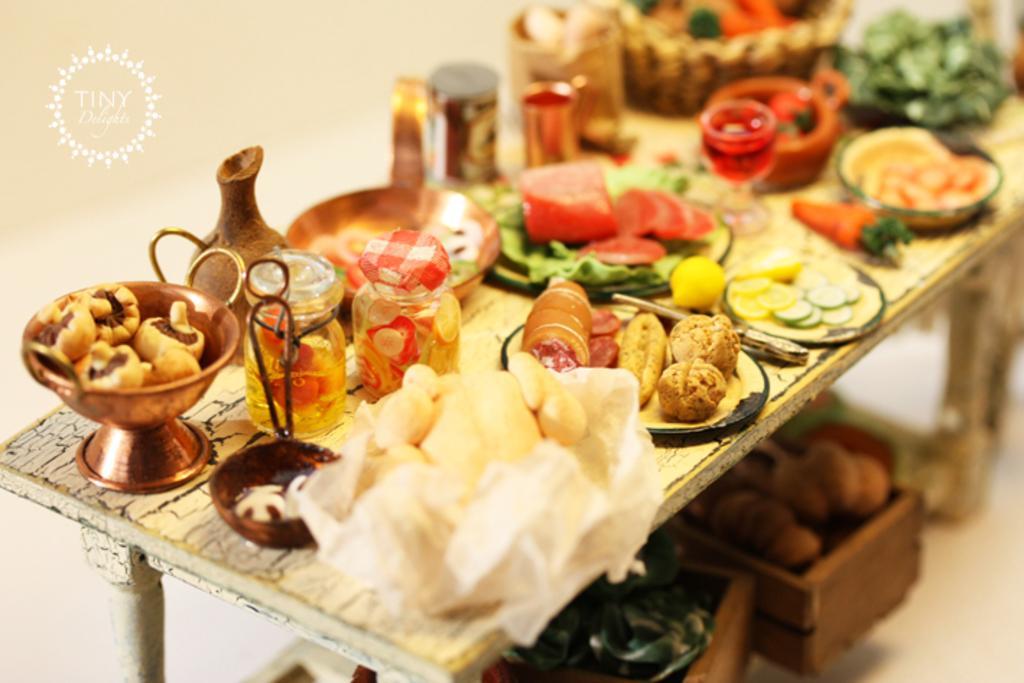How would you summarize this image in a sentence or two? In this image, we can see a table, on the table, we can see plate with some food item, carrot, bowl, jar, two bottles, cup, tissue, basket with some food item, green color leaves, glass, knife, under the table, we can see two baskets with some vegetables. 